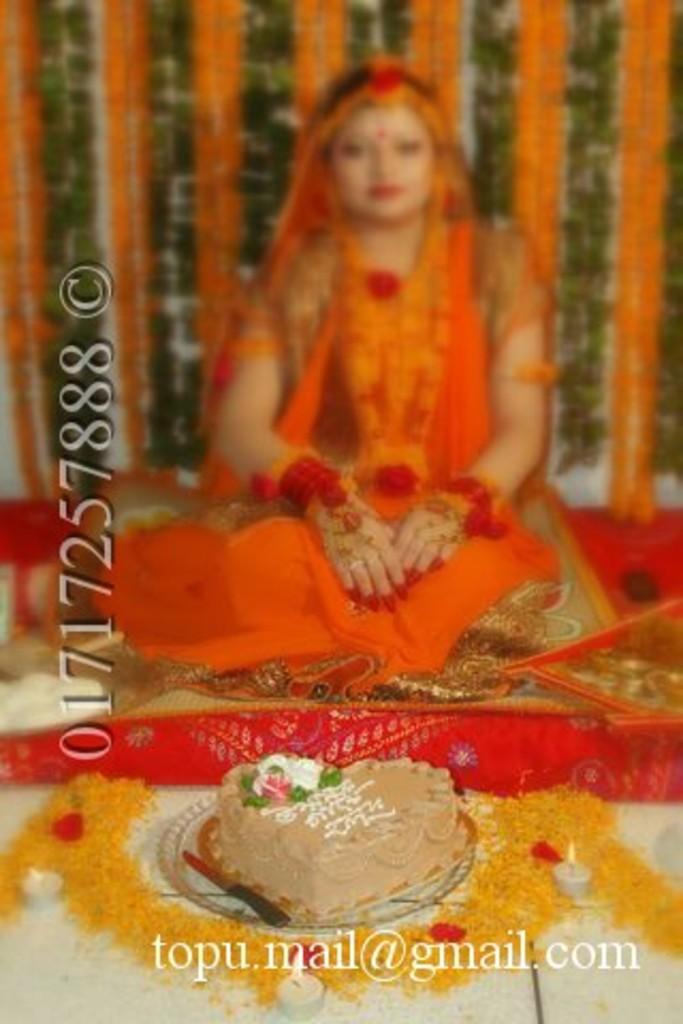In one or two sentences, can you explain what this image depicts? In this image there is a cake, flowers, candles, a person sitting on a carpet, and there are watermarks on the image. 